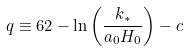<formula> <loc_0><loc_0><loc_500><loc_500>q \equiv 6 2 - \ln \left ( \frac { k _ { * } } { a _ { 0 } H _ { 0 } } \right ) - c</formula> 